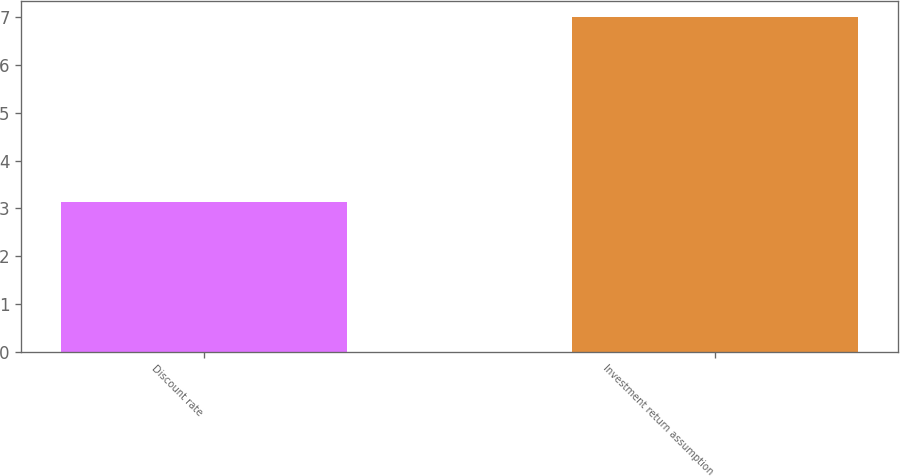Convert chart to OTSL. <chart><loc_0><loc_0><loc_500><loc_500><bar_chart><fcel>Discount rate<fcel>Investment return assumption<nl><fcel>3.14<fcel>7<nl></chart> 